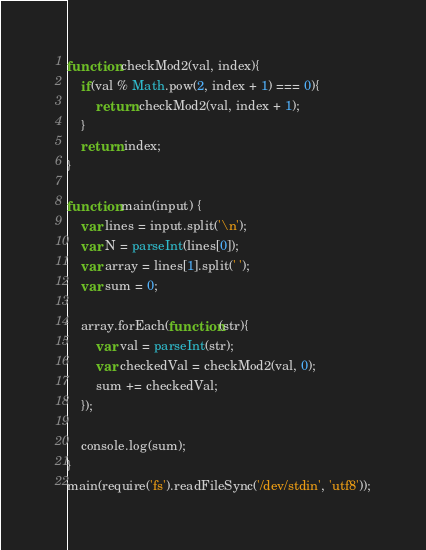Convert code to text. <code><loc_0><loc_0><loc_500><loc_500><_JavaScript_>
function checkMod2(val, index){
    if(val % Math.pow(2, index + 1) === 0){
        return checkMod2(val, index + 1);
    }
    return index;
}

function main(input) {
    var lines = input.split('\n');
    var N = parseInt(lines[0]);
    var array = lines[1].split(' ');
    var sum = 0;

    array.forEach(function(str){
        var val = parseInt(str);
        var checkedVal = checkMod2(val, 0);
        sum += checkedVal;
    });

    console.log(sum);
}
main(require('fs').readFileSync('/dev/stdin', 'utf8'));</code> 